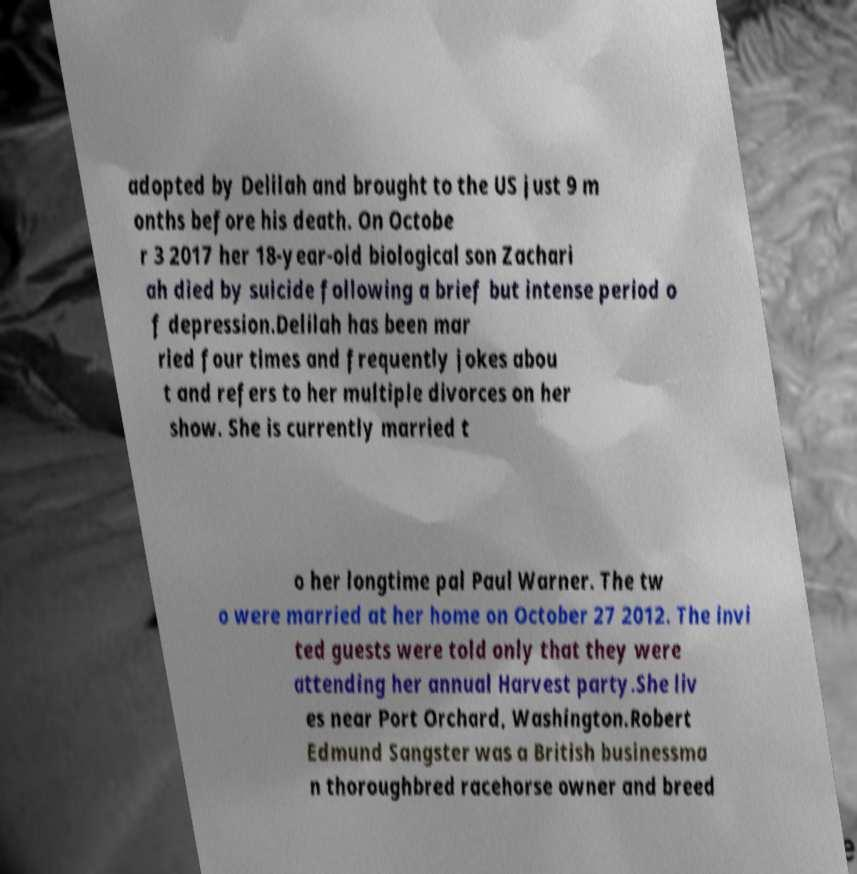Could you assist in decoding the text presented in this image and type it out clearly? adopted by Delilah and brought to the US just 9 m onths before his death. On Octobe r 3 2017 her 18-year-old biological son Zachari ah died by suicide following a brief but intense period o f depression.Delilah has been mar ried four times and frequently jokes abou t and refers to her multiple divorces on her show. She is currently married t o her longtime pal Paul Warner. The tw o were married at her home on October 27 2012. The invi ted guests were told only that they were attending her annual Harvest party.She liv es near Port Orchard, Washington.Robert Edmund Sangster was a British businessma n thoroughbred racehorse owner and breed 